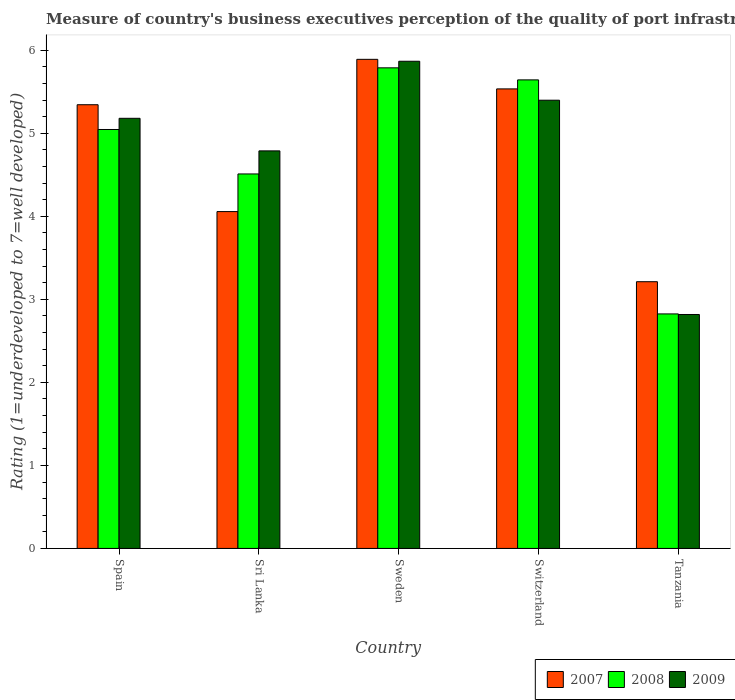How many different coloured bars are there?
Keep it short and to the point. 3. Are the number of bars per tick equal to the number of legend labels?
Give a very brief answer. Yes. How many bars are there on the 1st tick from the left?
Keep it short and to the point. 3. How many bars are there on the 2nd tick from the right?
Your answer should be compact. 3. What is the label of the 4th group of bars from the left?
Your answer should be very brief. Switzerland. What is the ratings of the quality of port infrastructure in 2009 in Sweden?
Your response must be concise. 5.87. Across all countries, what is the maximum ratings of the quality of port infrastructure in 2008?
Your answer should be compact. 5.79. Across all countries, what is the minimum ratings of the quality of port infrastructure in 2008?
Your response must be concise. 2.82. In which country was the ratings of the quality of port infrastructure in 2009 minimum?
Offer a terse response. Tanzania. What is the total ratings of the quality of port infrastructure in 2008 in the graph?
Your answer should be very brief. 23.81. What is the difference between the ratings of the quality of port infrastructure in 2008 in Switzerland and that in Tanzania?
Your response must be concise. 2.82. What is the difference between the ratings of the quality of port infrastructure in 2007 in Spain and the ratings of the quality of port infrastructure in 2009 in Tanzania?
Provide a short and direct response. 2.53. What is the average ratings of the quality of port infrastructure in 2007 per country?
Provide a short and direct response. 4.81. What is the difference between the ratings of the quality of port infrastructure of/in 2007 and ratings of the quality of port infrastructure of/in 2009 in Sri Lanka?
Offer a terse response. -0.73. What is the ratio of the ratings of the quality of port infrastructure in 2008 in Sweden to that in Switzerland?
Offer a very short reply. 1.03. Is the difference between the ratings of the quality of port infrastructure in 2007 in Switzerland and Tanzania greater than the difference between the ratings of the quality of port infrastructure in 2009 in Switzerland and Tanzania?
Provide a short and direct response. No. What is the difference between the highest and the second highest ratings of the quality of port infrastructure in 2009?
Ensure brevity in your answer.  -0.47. What is the difference between the highest and the lowest ratings of the quality of port infrastructure in 2007?
Offer a very short reply. 2.68. Is the sum of the ratings of the quality of port infrastructure in 2007 in Sweden and Switzerland greater than the maximum ratings of the quality of port infrastructure in 2008 across all countries?
Provide a short and direct response. Yes. What does the 3rd bar from the left in Spain represents?
Keep it short and to the point. 2009. What does the 2nd bar from the right in Tanzania represents?
Offer a terse response. 2008. Is it the case that in every country, the sum of the ratings of the quality of port infrastructure in 2007 and ratings of the quality of port infrastructure in 2008 is greater than the ratings of the quality of port infrastructure in 2009?
Give a very brief answer. Yes. How many bars are there?
Your response must be concise. 15. Are all the bars in the graph horizontal?
Offer a terse response. No. How many countries are there in the graph?
Provide a short and direct response. 5. What is the difference between two consecutive major ticks on the Y-axis?
Your answer should be very brief. 1. Are the values on the major ticks of Y-axis written in scientific E-notation?
Offer a very short reply. No. Does the graph contain any zero values?
Keep it short and to the point. No. What is the title of the graph?
Make the answer very short. Measure of country's business executives perception of the quality of port infrastructure. Does "1983" appear as one of the legend labels in the graph?
Offer a very short reply. No. What is the label or title of the X-axis?
Your response must be concise. Country. What is the label or title of the Y-axis?
Provide a short and direct response. Rating (1=underdeveloped to 7=well developed). What is the Rating (1=underdeveloped to 7=well developed) in 2007 in Spain?
Your answer should be compact. 5.34. What is the Rating (1=underdeveloped to 7=well developed) of 2008 in Spain?
Offer a terse response. 5.05. What is the Rating (1=underdeveloped to 7=well developed) in 2009 in Spain?
Give a very brief answer. 5.18. What is the Rating (1=underdeveloped to 7=well developed) in 2007 in Sri Lanka?
Provide a short and direct response. 4.06. What is the Rating (1=underdeveloped to 7=well developed) of 2008 in Sri Lanka?
Offer a very short reply. 4.51. What is the Rating (1=underdeveloped to 7=well developed) in 2009 in Sri Lanka?
Give a very brief answer. 4.79. What is the Rating (1=underdeveloped to 7=well developed) of 2007 in Sweden?
Give a very brief answer. 5.89. What is the Rating (1=underdeveloped to 7=well developed) in 2008 in Sweden?
Your answer should be compact. 5.79. What is the Rating (1=underdeveloped to 7=well developed) in 2009 in Sweden?
Offer a terse response. 5.87. What is the Rating (1=underdeveloped to 7=well developed) of 2007 in Switzerland?
Your response must be concise. 5.53. What is the Rating (1=underdeveloped to 7=well developed) in 2008 in Switzerland?
Offer a very short reply. 5.64. What is the Rating (1=underdeveloped to 7=well developed) in 2009 in Switzerland?
Your answer should be very brief. 5.4. What is the Rating (1=underdeveloped to 7=well developed) in 2007 in Tanzania?
Your answer should be very brief. 3.21. What is the Rating (1=underdeveloped to 7=well developed) of 2008 in Tanzania?
Provide a succinct answer. 2.82. What is the Rating (1=underdeveloped to 7=well developed) in 2009 in Tanzania?
Offer a very short reply. 2.82. Across all countries, what is the maximum Rating (1=underdeveloped to 7=well developed) in 2007?
Ensure brevity in your answer.  5.89. Across all countries, what is the maximum Rating (1=underdeveloped to 7=well developed) in 2008?
Give a very brief answer. 5.79. Across all countries, what is the maximum Rating (1=underdeveloped to 7=well developed) of 2009?
Provide a short and direct response. 5.87. Across all countries, what is the minimum Rating (1=underdeveloped to 7=well developed) in 2007?
Provide a succinct answer. 3.21. Across all countries, what is the minimum Rating (1=underdeveloped to 7=well developed) in 2008?
Keep it short and to the point. 2.82. Across all countries, what is the minimum Rating (1=underdeveloped to 7=well developed) in 2009?
Your answer should be compact. 2.82. What is the total Rating (1=underdeveloped to 7=well developed) of 2007 in the graph?
Give a very brief answer. 24.04. What is the total Rating (1=underdeveloped to 7=well developed) in 2008 in the graph?
Offer a very short reply. 23.81. What is the total Rating (1=underdeveloped to 7=well developed) in 2009 in the graph?
Keep it short and to the point. 24.05. What is the difference between the Rating (1=underdeveloped to 7=well developed) of 2007 in Spain and that in Sri Lanka?
Your answer should be very brief. 1.29. What is the difference between the Rating (1=underdeveloped to 7=well developed) of 2008 in Spain and that in Sri Lanka?
Offer a terse response. 0.54. What is the difference between the Rating (1=underdeveloped to 7=well developed) in 2009 in Spain and that in Sri Lanka?
Keep it short and to the point. 0.39. What is the difference between the Rating (1=underdeveloped to 7=well developed) of 2007 in Spain and that in Sweden?
Keep it short and to the point. -0.55. What is the difference between the Rating (1=underdeveloped to 7=well developed) in 2008 in Spain and that in Sweden?
Offer a very short reply. -0.74. What is the difference between the Rating (1=underdeveloped to 7=well developed) in 2009 in Spain and that in Sweden?
Offer a very short reply. -0.69. What is the difference between the Rating (1=underdeveloped to 7=well developed) in 2007 in Spain and that in Switzerland?
Your answer should be very brief. -0.19. What is the difference between the Rating (1=underdeveloped to 7=well developed) in 2008 in Spain and that in Switzerland?
Your answer should be very brief. -0.6. What is the difference between the Rating (1=underdeveloped to 7=well developed) of 2009 in Spain and that in Switzerland?
Ensure brevity in your answer.  -0.22. What is the difference between the Rating (1=underdeveloped to 7=well developed) in 2007 in Spain and that in Tanzania?
Your answer should be compact. 2.13. What is the difference between the Rating (1=underdeveloped to 7=well developed) in 2008 in Spain and that in Tanzania?
Provide a succinct answer. 2.22. What is the difference between the Rating (1=underdeveloped to 7=well developed) of 2009 in Spain and that in Tanzania?
Offer a terse response. 2.36. What is the difference between the Rating (1=underdeveloped to 7=well developed) in 2007 in Sri Lanka and that in Sweden?
Give a very brief answer. -1.83. What is the difference between the Rating (1=underdeveloped to 7=well developed) in 2008 in Sri Lanka and that in Sweden?
Provide a succinct answer. -1.28. What is the difference between the Rating (1=underdeveloped to 7=well developed) in 2009 in Sri Lanka and that in Sweden?
Your answer should be compact. -1.08. What is the difference between the Rating (1=underdeveloped to 7=well developed) of 2007 in Sri Lanka and that in Switzerland?
Your answer should be very brief. -1.48. What is the difference between the Rating (1=underdeveloped to 7=well developed) of 2008 in Sri Lanka and that in Switzerland?
Your response must be concise. -1.13. What is the difference between the Rating (1=underdeveloped to 7=well developed) in 2009 in Sri Lanka and that in Switzerland?
Keep it short and to the point. -0.61. What is the difference between the Rating (1=underdeveloped to 7=well developed) of 2007 in Sri Lanka and that in Tanzania?
Give a very brief answer. 0.84. What is the difference between the Rating (1=underdeveloped to 7=well developed) of 2008 in Sri Lanka and that in Tanzania?
Keep it short and to the point. 1.69. What is the difference between the Rating (1=underdeveloped to 7=well developed) of 2009 in Sri Lanka and that in Tanzania?
Your response must be concise. 1.97. What is the difference between the Rating (1=underdeveloped to 7=well developed) in 2007 in Sweden and that in Switzerland?
Your response must be concise. 0.36. What is the difference between the Rating (1=underdeveloped to 7=well developed) in 2008 in Sweden and that in Switzerland?
Provide a succinct answer. 0.15. What is the difference between the Rating (1=underdeveloped to 7=well developed) in 2009 in Sweden and that in Switzerland?
Provide a succinct answer. 0.47. What is the difference between the Rating (1=underdeveloped to 7=well developed) of 2007 in Sweden and that in Tanzania?
Offer a very short reply. 2.68. What is the difference between the Rating (1=underdeveloped to 7=well developed) in 2008 in Sweden and that in Tanzania?
Offer a very short reply. 2.96. What is the difference between the Rating (1=underdeveloped to 7=well developed) of 2009 in Sweden and that in Tanzania?
Offer a terse response. 3.05. What is the difference between the Rating (1=underdeveloped to 7=well developed) in 2007 in Switzerland and that in Tanzania?
Make the answer very short. 2.32. What is the difference between the Rating (1=underdeveloped to 7=well developed) in 2008 in Switzerland and that in Tanzania?
Offer a terse response. 2.82. What is the difference between the Rating (1=underdeveloped to 7=well developed) of 2009 in Switzerland and that in Tanzania?
Your response must be concise. 2.58. What is the difference between the Rating (1=underdeveloped to 7=well developed) in 2007 in Spain and the Rating (1=underdeveloped to 7=well developed) in 2008 in Sri Lanka?
Your response must be concise. 0.83. What is the difference between the Rating (1=underdeveloped to 7=well developed) in 2007 in Spain and the Rating (1=underdeveloped to 7=well developed) in 2009 in Sri Lanka?
Keep it short and to the point. 0.56. What is the difference between the Rating (1=underdeveloped to 7=well developed) of 2008 in Spain and the Rating (1=underdeveloped to 7=well developed) of 2009 in Sri Lanka?
Your answer should be compact. 0.26. What is the difference between the Rating (1=underdeveloped to 7=well developed) of 2007 in Spain and the Rating (1=underdeveloped to 7=well developed) of 2008 in Sweden?
Offer a very short reply. -0.44. What is the difference between the Rating (1=underdeveloped to 7=well developed) in 2007 in Spain and the Rating (1=underdeveloped to 7=well developed) in 2009 in Sweden?
Your answer should be very brief. -0.52. What is the difference between the Rating (1=underdeveloped to 7=well developed) in 2008 in Spain and the Rating (1=underdeveloped to 7=well developed) in 2009 in Sweden?
Provide a succinct answer. -0.82. What is the difference between the Rating (1=underdeveloped to 7=well developed) of 2007 in Spain and the Rating (1=underdeveloped to 7=well developed) of 2008 in Switzerland?
Offer a very short reply. -0.3. What is the difference between the Rating (1=underdeveloped to 7=well developed) in 2007 in Spain and the Rating (1=underdeveloped to 7=well developed) in 2009 in Switzerland?
Your answer should be very brief. -0.05. What is the difference between the Rating (1=underdeveloped to 7=well developed) in 2008 in Spain and the Rating (1=underdeveloped to 7=well developed) in 2009 in Switzerland?
Give a very brief answer. -0.35. What is the difference between the Rating (1=underdeveloped to 7=well developed) of 2007 in Spain and the Rating (1=underdeveloped to 7=well developed) of 2008 in Tanzania?
Ensure brevity in your answer.  2.52. What is the difference between the Rating (1=underdeveloped to 7=well developed) of 2007 in Spain and the Rating (1=underdeveloped to 7=well developed) of 2009 in Tanzania?
Provide a succinct answer. 2.53. What is the difference between the Rating (1=underdeveloped to 7=well developed) of 2008 in Spain and the Rating (1=underdeveloped to 7=well developed) of 2009 in Tanzania?
Offer a very short reply. 2.23. What is the difference between the Rating (1=underdeveloped to 7=well developed) of 2007 in Sri Lanka and the Rating (1=underdeveloped to 7=well developed) of 2008 in Sweden?
Offer a very short reply. -1.73. What is the difference between the Rating (1=underdeveloped to 7=well developed) of 2007 in Sri Lanka and the Rating (1=underdeveloped to 7=well developed) of 2009 in Sweden?
Your answer should be very brief. -1.81. What is the difference between the Rating (1=underdeveloped to 7=well developed) in 2008 in Sri Lanka and the Rating (1=underdeveloped to 7=well developed) in 2009 in Sweden?
Give a very brief answer. -1.36. What is the difference between the Rating (1=underdeveloped to 7=well developed) of 2007 in Sri Lanka and the Rating (1=underdeveloped to 7=well developed) of 2008 in Switzerland?
Make the answer very short. -1.59. What is the difference between the Rating (1=underdeveloped to 7=well developed) of 2007 in Sri Lanka and the Rating (1=underdeveloped to 7=well developed) of 2009 in Switzerland?
Make the answer very short. -1.34. What is the difference between the Rating (1=underdeveloped to 7=well developed) in 2008 in Sri Lanka and the Rating (1=underdeveloped to 7=well developed) in 2009 in Switzerland?
Give a very brief answer. -0.89. What is the difference between the Rating (1=underdeveloped to 7=well developed) of 2007 in Sri Lanka and the Rating (1=underdeveloped to 7=well developed) of 2008 in Tanzania?
Provide a short and direct response. 1.23. What is the difference between the Rating (1=underdeveloped to 7=well developed) of 2007 in Sri Lanka and the Rating (1=underdeveloped to 7=well developed) of 2009 in Tanzania?
Your answer should be very brief. 1.24. What is the difference between the Rating (1=underdeveloped to 7=well developed) of 2008 in Sri Lanka and the Rating (1=underdeveloped to 7=well developed) of 2009 in Tanzania?
Your answer should be compact. 1.69. What is the difference between the Rating (1=underdeveloped to 7=well developed) in 2007 in Sweden and the Rating (1=underdeveloped to 7=well developed) in 2008 in Switzerland?
Offer a very short reply. 0.25. What is the difference between the Rating (1=underdeveloped to 7=well developed) of 2007 in Sweden and the Rating (1=underdeveloped to 7=well developed) of 2009 in Switzerland?
Your answer should be compact. 0.49. What is the difference between the Rating (1=underdeveloped to 7=well developed) of 2008 in Sweden and the Rating (1=underdeveloped to 7=well developed) of 2009 in Switzerland?
Your answer should be compact. 0.39. What is the difference between the Rating (1=underdeveloped to 7=well developed) of 2007 in Sweden and the Rating (1=underdeveloped to 7=well developed) of 2008 in Tanzania?
Your answer should be compact. 3.07. What is the difference between the Rating (1=underdeveloped to 7=well developed) in 2007 in Sweden and the Rating (1=underdeveloped to 7=well developed) in 2009 in Tanzania?
Your response must be concise. 3.07. What is the difference between the Rating (1=underdeveloped to 7=well developed) in 2008 in Sweden and the Rating (1=underdeveloped to 7=well developed) in 2009 in Tanzania?
Offer a terse response. 2.97. What is the difference between the Rating (1=underdeveloped to 7=well developed) of 2007 in Switzerland and the Rating (1=underdeveloped to 7=well developed) of 2008 in Tanzania?
Make the answer very short. 2.71. What is the difference between the Rating (1=underdeveloped to 7=well developed) of 2007 in Switzerland and the Rating (1=underdeveloped to 7=well developed) of 2009 in Tanzania?
Your answer should be compact. 2.72. What is the difference between the Rating (1=underdeveloped to 7=well developed) in 2008 in Switzerland and the Rating (1=underdeveloped to 7=well developed) in 2009 in Tanzania?
Provide a short and direct response. 2.83. What is the average Rating (1=underdeveloped to 7=well developed) of 2007 per country?
Your answer should be very brief. 4.81. What is the average Rating (1=underdeveloped to 7=well developed) of 2008 per country?
Ensure brevity in your answer.  4.76. What is the average Rating (1=underdeveloped to 7=well developed) of 2009 per country?
Give a very brief answer. 4.81. What is the difference between the Rating (1=underdeveloped to 7=well developed) in 2007 and Rating (1=underdeveloped to 7=well developed) in 2008 in Spain?
Ensure brevity in your answer.  0.3. What is the difference between the Rating (1=underdeveloped to 7=well developed) of 2007 and Rating (1=underdeveloped to 7=well developed) of 2009 in Spain?
Give a very brief answer. 0.16. What is the difference between the Rating (1=underdeveloped to 7=well developed) of 2008 and Rating (1=underdeveloped to 7=well developed) of 2009 in Spain?
Make the answer very short. -0.13. What is the difference between the Rating (1=underdeveloped to 7=well developed) of 2007 and Rating (1=underdeveloped to 7=well developed) of 2008 in Sri Lanka?
Offer a very short reply. -0.45. What is the difference between the Rating (1=underdeveloped to 7=well developed) of 2007 and Rating (1=underdeveloped to 7=well developed) of 2009 in Sri Lanka?
Your answer should be compact. -0.73. What is the difference between the Rating (1=underdeveloped to 7=well developed) in 2008 and Rating (1=underdeveloped to 7=well developed) in 2009 in Sri Lanka?
Keep it short and to the point. -0.28. What is the difference between the Rating (1=underdeveloped to 7=well developed) of 2007 and Rating (1=underdeveloped to 7=well developed) of 2008 in Sweden?
Keep it short and to the point. 0.1. What is the difference between the Rating (1=underdeveloped to 7=well developed) in 2007 and Rating (1=underdeveloped to 7=well developed) in 2009 in Sweden?
Keep it short and to the point. 0.02. What is the difference between the Rating (1=underdeveloped to 7=well developed) in 2008 and Rating (1=underdeveloped to 7=well developed) in 2009 in Sweden?
Provide a short and direct response. -0.08. What is the difference between the Rating (1=underdeveloped to 7=well developed) in 2007 and Rating (1=underdeveloped to 7=well developed) in 2008 in Switzerland?
Keep it short and to the point. -0.11. What is the difference between the Rating (1=underdeveloped to 7=well developed) of 2007 and Rating (1=underdeveloped to 7=well developed) of 2009 in Switzerland?
Provide a succinct answer. 0.14. What is the difference between the Rating (1=underdeveloped to 7=well developed) of 2008 and Rating (1=underdeveloped to 7=well developed) of 2009 in Switzerland?
Make the answer very short. 0.24. What is the difference between the Rating (1=underdeveloped to 7=well developed) in 2007 and Rating (1=underdeveloped to 7=well developed) in 2008 in Tanzania?
Your response must be concise. 0.39. What is the difference between the Rating (1=underdeveloped to 7=well developed) in 2007 and Rating (1=underdeveloped to 7=well developed) in 2009 in Tanzania?
Make the answer very short. 0.39. What is the difference between the Rating (1=underdeveloped to 7=well developed) of 2008 and Rating (1=underdeveloped to 7=well developed) of 2009 in Tanzania?
Provide a succinct answer. 0.01. What is the ratio of the Rating (1=underdeveloped to 7=well developed) of 2007 in Spain to that in Sri Lanka?
Your answer should be compact. 1.32. What is the ratio of the Rating (1=underdeveloped to 7=well developed) in 2008 in Spain to that in Sri Lanka?
Offer a very short reply. 1.12. What is the ratio of the Rating (1=underdeveloped to 7=well developed) in 2009 in Spain to that in Sri Lanka?
Give a very brief answer. 1.08. What is the ratio of the Rating (1=underdeveloped to 7=well developed) in 2007 in Spain to that in Sweden?
Your answer should be very brief. 0.91. What is the ratio of the Rating (1=underdeveloped to 7=well developed) of 2008 in Spain to that in Sweden?
Keep it short and to the point. 0.87. What is the ratio of the Rating (1=underdeveloped to 7=well developed) of 2009 in Spain to that in Sweden?
Keep it short and to the point. 0.88. What is the ratio of the Rating (1=underdeveloped to 7=well developed) in 2007 in Spain to that in Switzerland?
Offer a terse response. 0.97. What is the ratio of the Rating (1=underdeveloped to 7=well developed) of 2008 in Spain to that in Switzerland?
Offer a very short reply. 0.89. What is the ratio of the Rating (1=underdeveloped to 7=well developed) of 2009 in Spain to that in Switzerland?
Your answer should be very brief. 0.96. What is the ratio of the Rating (1=underdeveloped to 7=well developed) in 2007 in Spain to that in Tanzania?
Offer a very short reply. 1.66. What is the ratio of the Rating (1=underdeveloped to 7=well developed) in 2008 in Spain to that in Tanzania?
Offer a very short reply. 1.79. What is the ratio of the Rating (1=underdeveloped to 7=well developed) in 2009 in Spain to that in Tanzania?
Your answer should be compact. 1.84. What is the ratio of the Rating (1=underdeveloped to 7=well developed) of 2007 in Sri Lanka to that in Sweden?
Offer a terse response. 0.69. What is the ratio of the Rating (1=underdeveloped to 7=well developed) of 2008 in Sri Lanka to that in Sweden?
Make the answer very short. 0.78. What is the ratio of the Rating (1=underdeveloped to 7=well developed) in 2009 in Sri Lanka to that in Sweden?
Offer a terse response. 0.82. What is the ratio of the Rating (1=underdeveloped to 7=well developed) of 2007 in Sri Lanka to that in Switzerland?
Make the answer very short. 0.73. What is the ratio of the Rating (1=underdeveloped to 7=well developed) in 2008 in Sri Lanka to that in Switzerland?
Provide a short and direct response. 0.8. What is the ratio of the Rating (1=underdeveloped to 7=well developed) in 2009 in Sri Lanka to that in Switzerland?
Give a very brief answer. 0.89. What is the ratio of the Rating (1=underdeveloped to 7=well developed) of 2007 in Sri Lanka to that in Tanzania?
Your answer should be compact. 1.26. What is the ratio of the Rating (1=underdeveloped to 7=well developed) in 2008 in Sri Lanka to that in Tanzania?
Make the answer very short. 1.6. What is the ratio of the Rating (1=underdeveloped to 7=well developed) of 2009 in Sri Lanka to that in Tanzania?
Your response must be concise. 1.7. What is the ratio of the Rating (1=underdeveloped to 7=well developed) in 2007 in Sweden to that in Switzerland?
Keep it short and to the point. 1.06. What is the ratio of the Rating (1=underdeveloped to 7=well developed) in 2008 in Sweden to that in Switzerland?
Keep it short and to the point. 1.03. What is the ratio of the Rating (1=underdeveloped to 7=well developed) of 2009 in Sweden to that in Switzerland?
Give a very brief answer. 1.09. What is the ratio of the Rating (1=underdeveloped to 7=well developed) in 2007 in Sweden to that in Tanzania?
Offer a very short reply. 1.83. What is the ratio of the Rating (1=underdeveloped to 7=well developed) of 2008 in Sweden to that in Tanzania?
Your response must be concise. 2.05. What is the ratio of the Rating (1=underdeveloped to 7=well developed) of 2009 in Sweden to that in Tanzania?
Ensure brevity in your answer.  2.08. What is the ratio of the Rating (1=underdeveloped to 7=well developed) of 2007 in Switzerland to that in Tanzania?
Give a very brief answer. 1.72. What is the ratio of the Rating (1=underdeveloped to 7=well developed) in 2008 in Switzerland to that in Tanzania?
Provide a succinct answer. 2. What is the ratio of the Rating (1=underdeveloped to 7=well developed) of 2009 in Switzerland to that in Tanzania?
Provide a succinct answer. 1.92. What is the difference between the highest and the second highest Rating (1=underdeveloped to 7=well developed) in 2007?
Provide a succinct answer. 0.36. What is the difference between the highest and the second highest Rating (1=underdeveloped to 7=well developed) of 2008?
Keep it short and to the point. 0.15. What is the difference between the highest and the second highest Rating (1=underdeveloped to 7=well developed) of 2009?
Your answer should be very brief. 0.47. What is the difference between the highest and the lowest Rating (1=underdeveloped to 7=well developed) of 2007?
Provide a short and direct response. 2.68. What is the difference between the highest and the lowest Rating (1=underdeveloped to 7=well developed) of 2008?
Offer a terse response. 2.96. What is the difference between the highest and the lowest Rating (1=underdeveloped to 7=well developed) of 2009?
Make the answer very short. 3.05. 